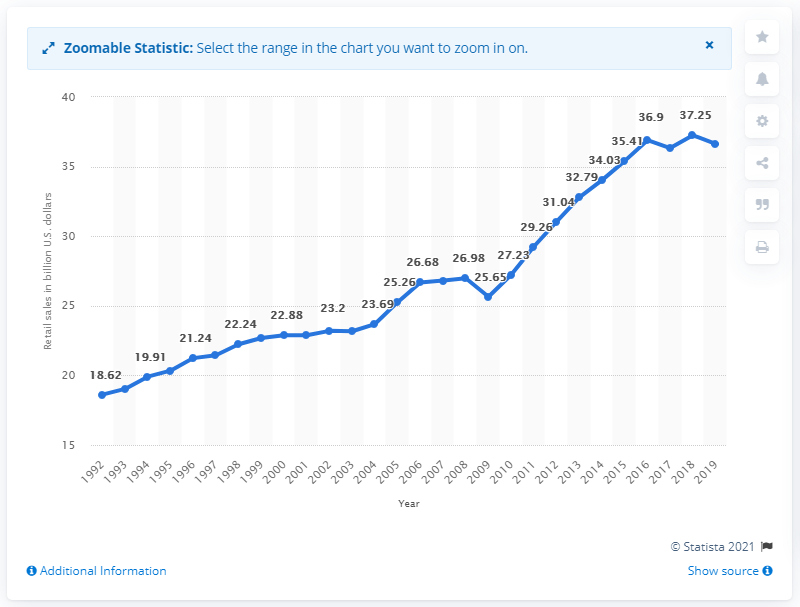Indicate a few pertinent items in this graphic. The sales at the shoe store in 2019 were $36.63.. 